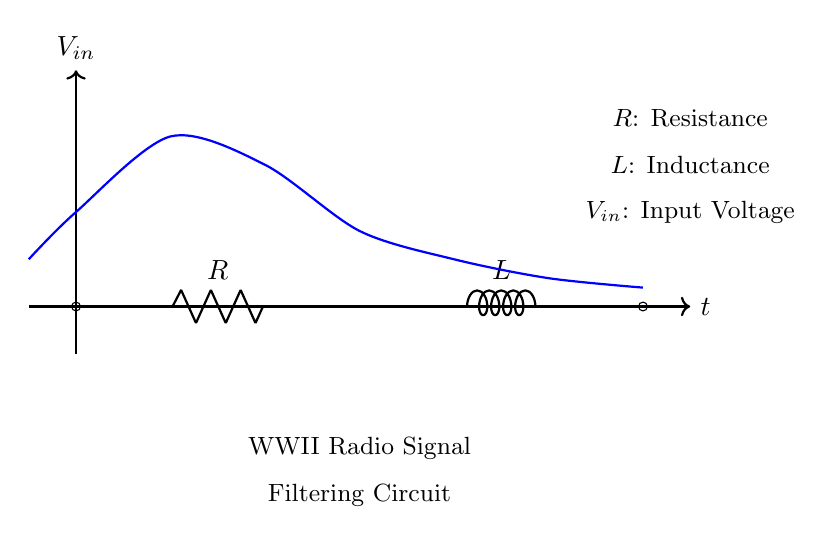What type of circuit is this? This is a resistor-inductor circuit, which consists of a resistor and an inductor connected in series. The circuit diagram shows a clear representation of both components.
Answer: Resistor-Inductor What do R and L represent in the circuit? R represents the resistance, which is a measure of the opposition to the flow of electric current, while L represents the inductance, which is the property of the inductor to store energy in a magnetic field. Both are labeled directly on the circuit diagram.
Answer: Resistance and Inductance What is the purpose of this circuit? The purpose of this circuit is to filter radio signals, which is indicated by the label "WWII Radio Signal Filtering Circuit." Its design allows it to selectively allow certain frequencies to pass while attenuating others.
Answer: Filtering radio signals What happens to high-frequency signals in this circuit? High-frequency signals are generally blocked or attenuated by the inductor due to its increasing reactance with frequency, which prevents them from passing through as efficiently. This follows the principle of a low-pass filter configuration.
Answer: Blocked or attenuated How does the inductor affect the circuit's response to input voltage? The inductor introduces a delay in current response to changes in input voltage due to its property of opposing changes in current. This lag results in a smoother voltage output over time compared to the input voltage, allowing the circuit to filter fluctuations effectively.
Answer: Introduces delay What role does the input voltage (Vin) play in this circuit? The input voltage (Vin) is the source of electrical energy that drives the circuit. It is what the circuit reacts to, affecting both the current through the resistor and the magnetic field in the inductor, thus influencing the filtering effect.
Answer: Source of electrical energy What can be inferred about the time response of this circuit? The time response of this circuit may exhibit characteristics of a first-order system, where the voltage across the circuit will change gradually rather than instantaneously due to the reactance of the inductor, affecting the signal's rise and fall times.
Answer: First-order system response 